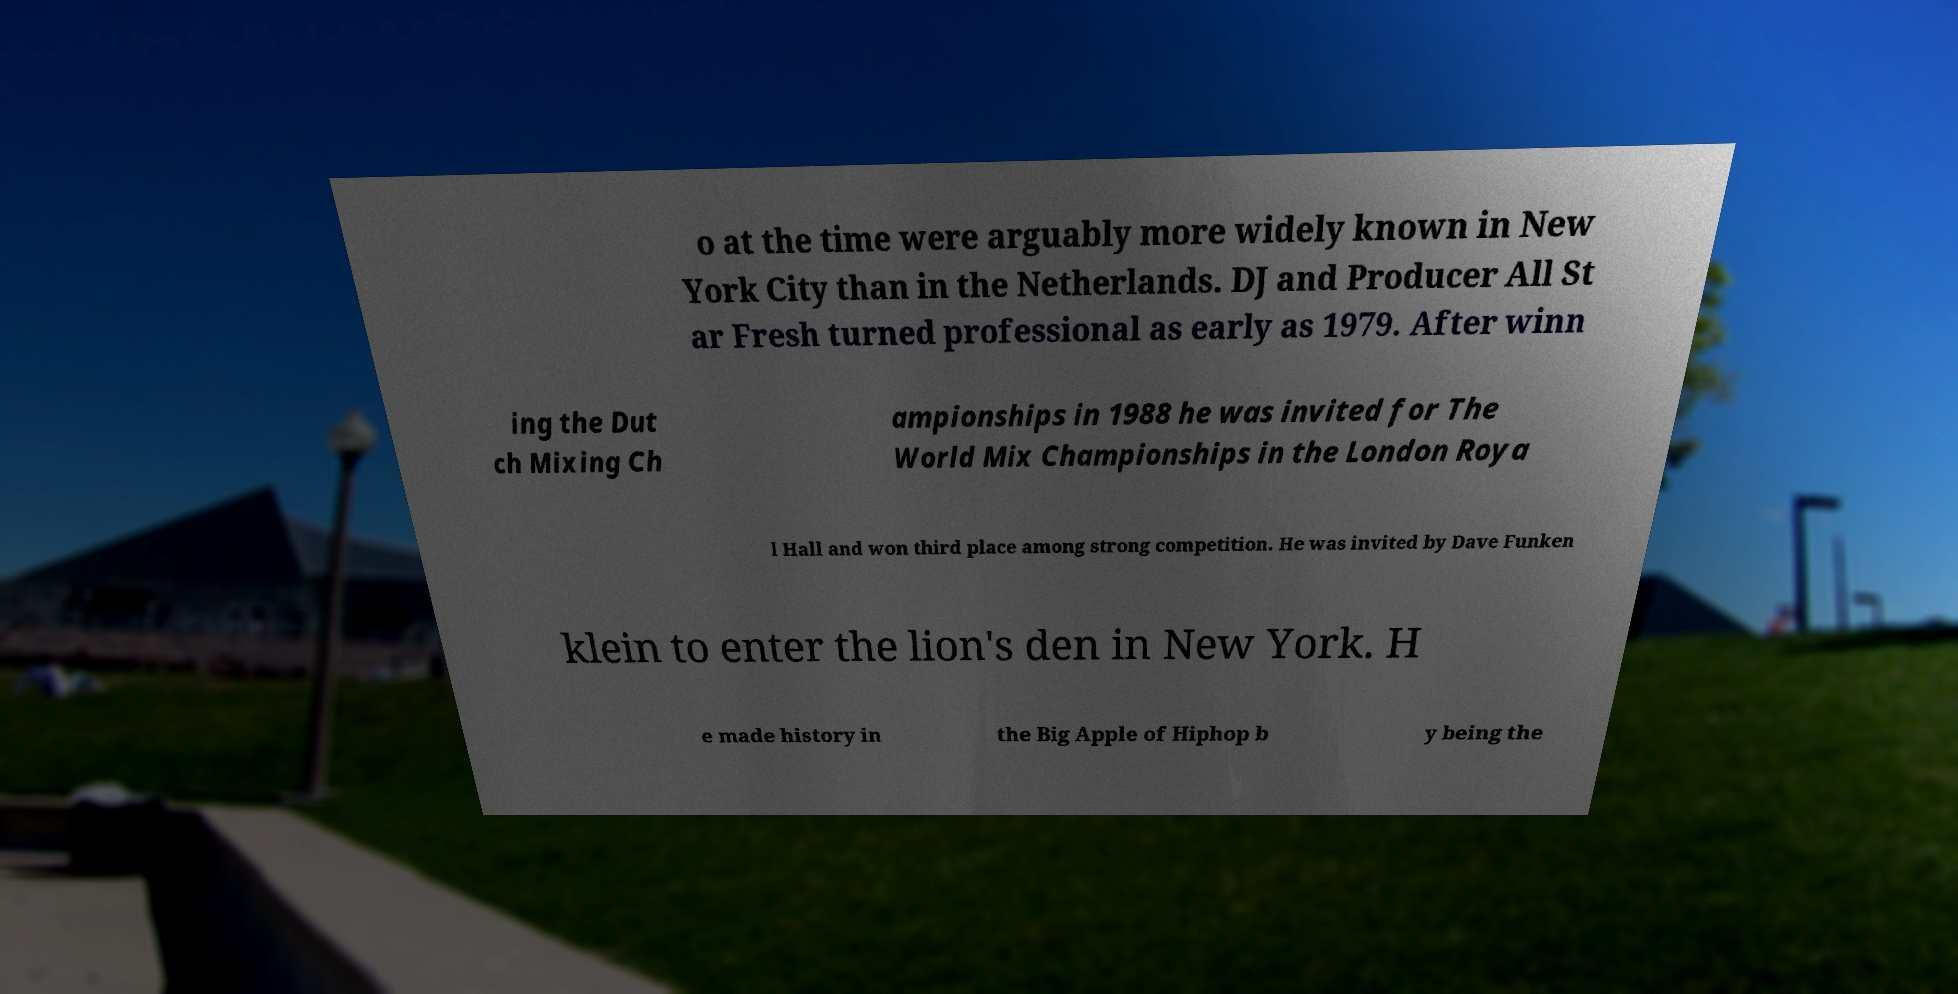There's text embedded in this image that I need extracted. Can you transcribe it verbatim? o at the time were arguably more widely known in New York City than in the Netherlands. DJ and Producer All St ar Fresh turned professional as early as 1979. After winn ing the Dut ch Mixing Ch ampionships in 1988 he was invited for The World Mix Championships in the London Roya l Hall and won third place among strong competition. He was invited by Dave Funken klein to enter the lion's den in New York. H e made history in the Big Apple of Hiphop b y being the 